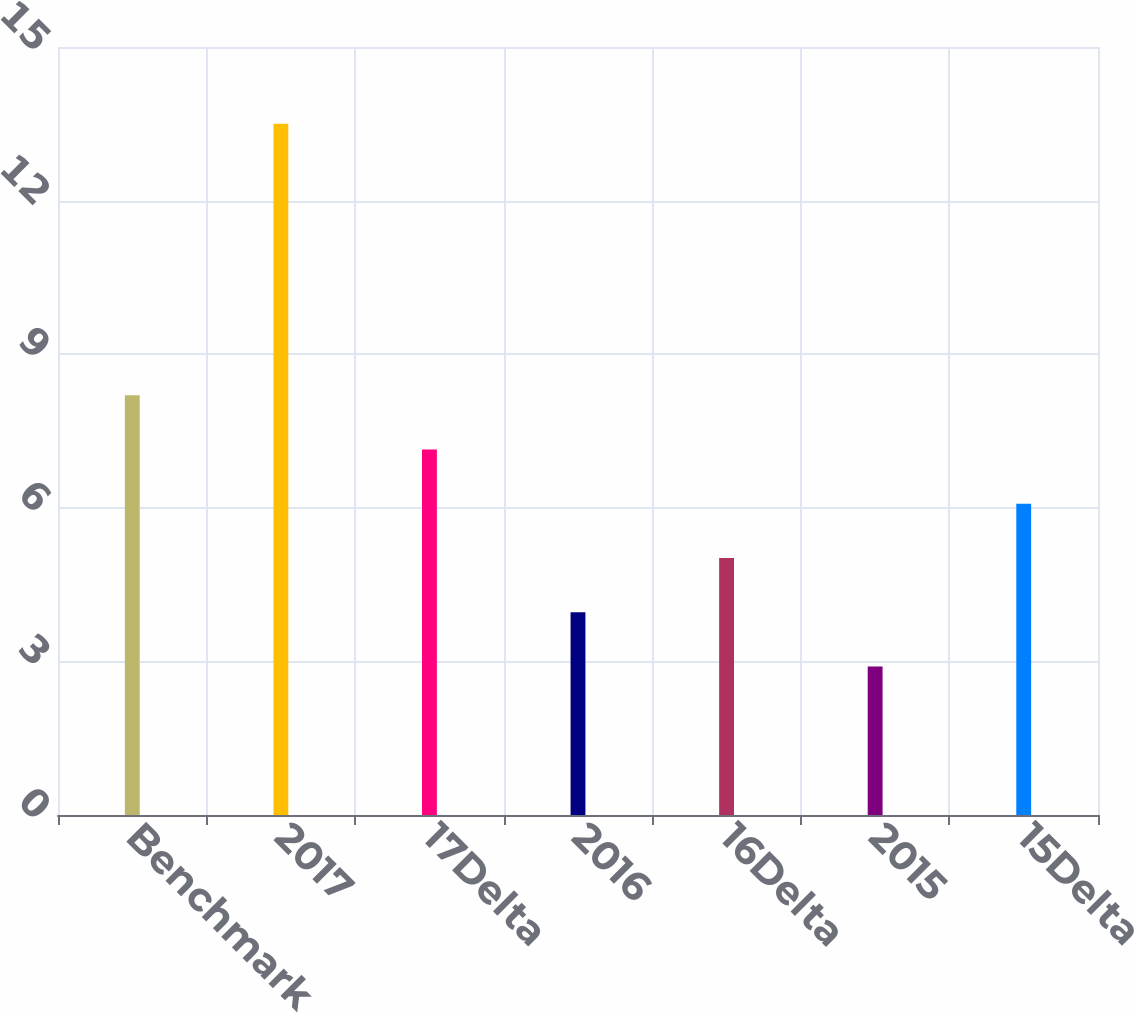Convert chart. <chart><loc_0><loc_0><loc_500><loc_500><bar_chart><fcel>Benchmark<fcel>2017<fcel>17Delta<fcel>2016<fcel>16Delta<fcel>2015<fcel>15Delta<nl><fcel>8.2<fcel>13.5<fcel>7.14<fcel>3.96<fcel>5.02<fcel>2.9<fcel>6.08<nl></chart> 